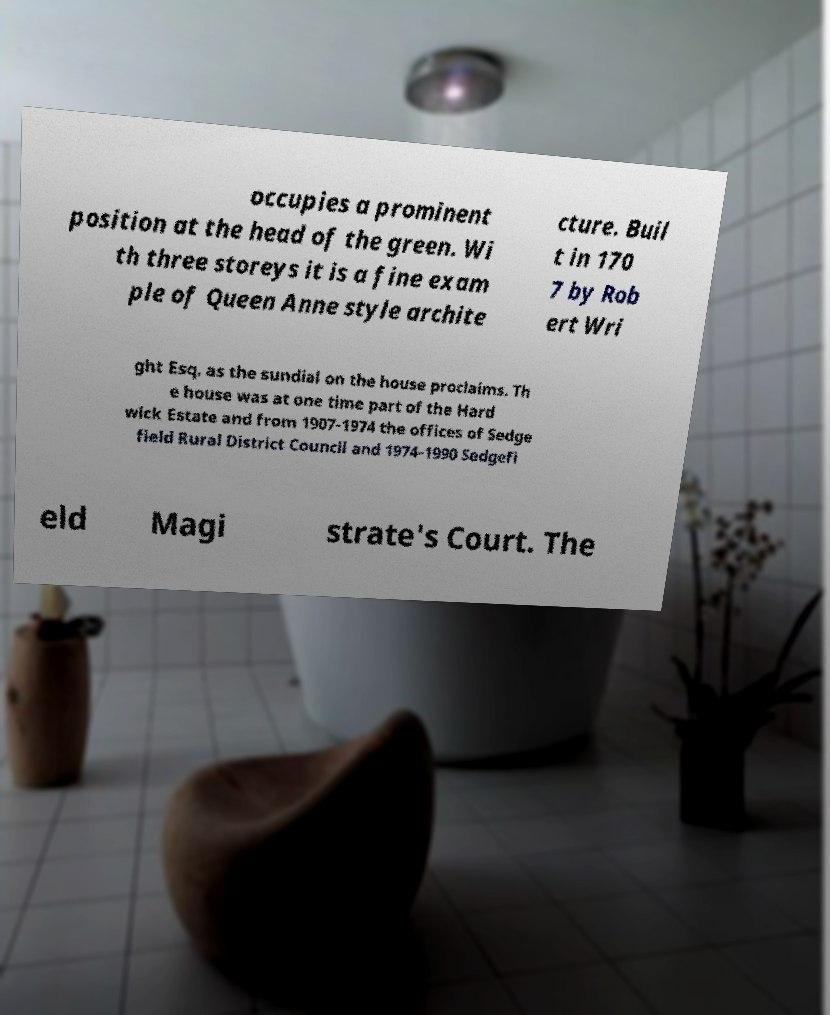There's text embedded in this image that I need extracted. Can you transcribe it verbatim? occupies a prominent position at the head of the green. Wi th three storeys it is a fine exam ple of Queen Anne style archite cture. Buil t in 170 7 by Rob ert Wri ght Esq. as the sundial on the house proclaims. Th e house was at one time part of the Hard wick Estate and from 1907-1974 the offices of Sedge field Rural District Council and 1974-1990 Sedgefi eld Magi strate's Court. The 